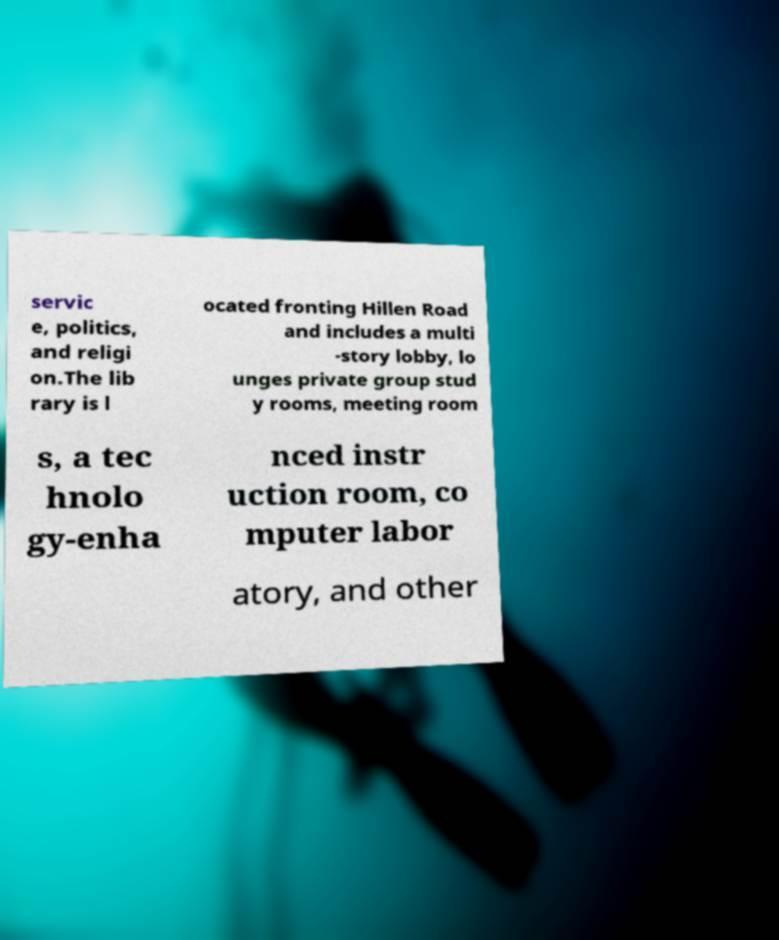Could you extract and type out the text from this image? servic e, politics, and religi on.The lib rary is l ocated fronting Hillen Road and includes a multi -story lobby, lo unges private group stud y rooms, meeting room s, a tec hnolo gy-enha nced instr uction room, co mputer labor atory, and other 